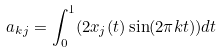<formula> <loc_0><loc_0><loc_500><loc_500>a _ { k j } = \int _ { 0 } ^ { 1 } ( 2 x _ { j } ( t ) \sin ( 2 \pi k t ) ) d t</formula> 